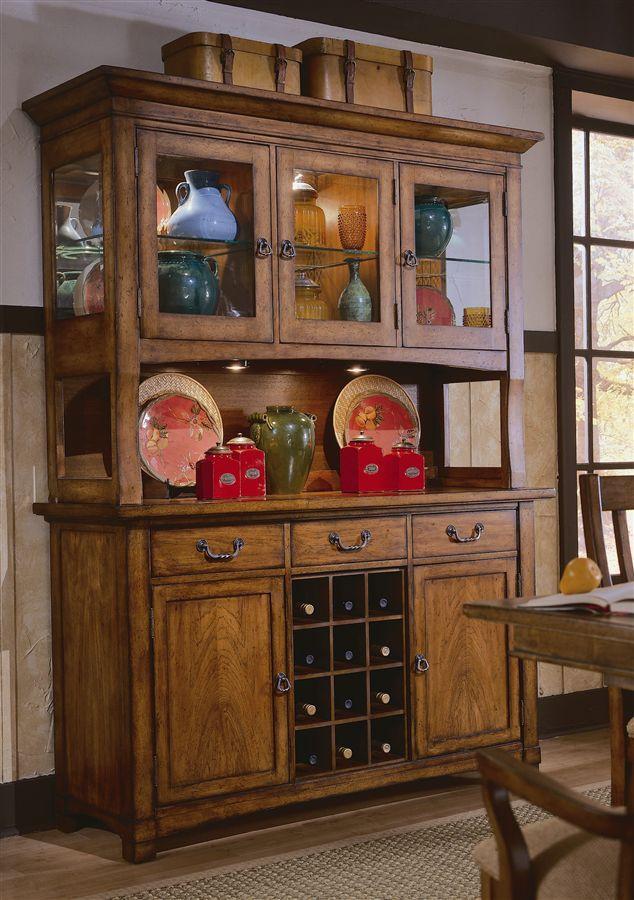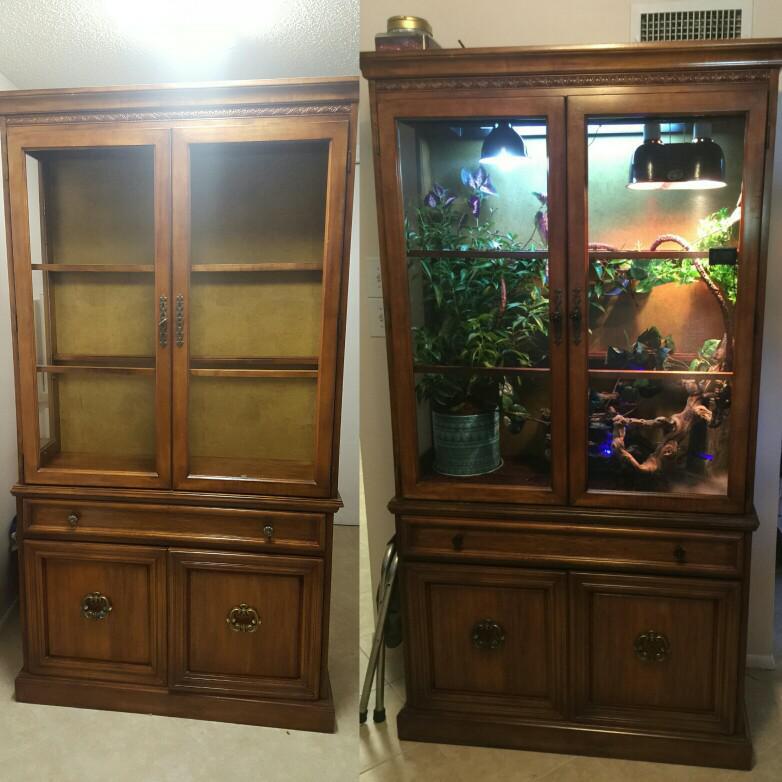The first image is the image on the left, the second image is the image on the right. For the images shown, is this caption "One china cabinet has three stacked drawers on the bottom and three upper shelves filled with dishes." true? Answer yes or no. No. 